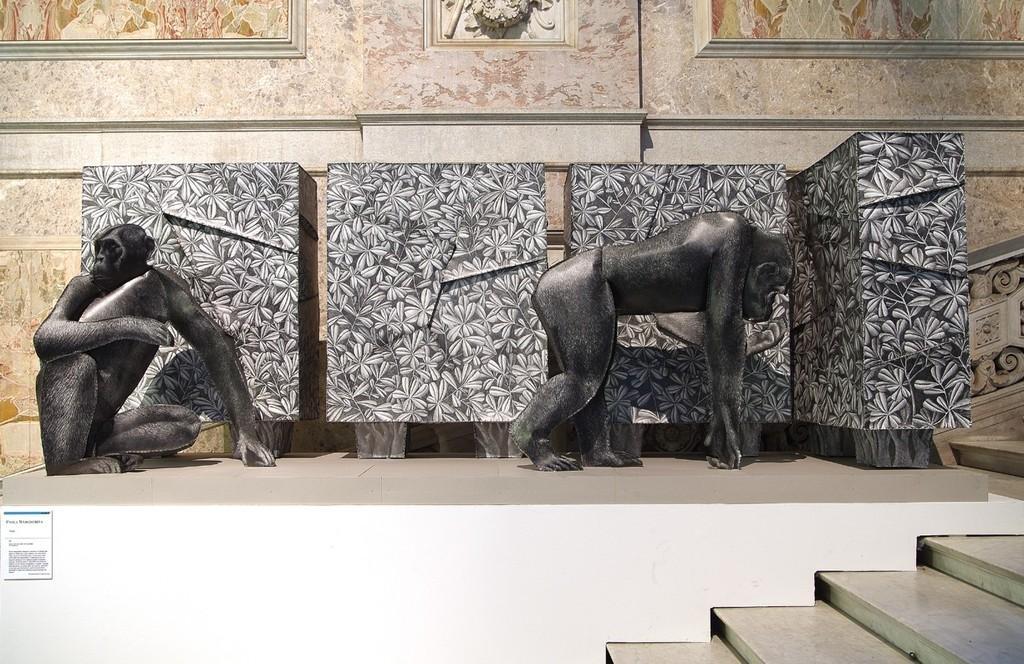In one or two sentences, can you explain what this image depicts? In this picture I can see the steps in front and in the middle of this picture I can see the sculptures of 2 monkeys. In the background I can see the designs on the walls. 